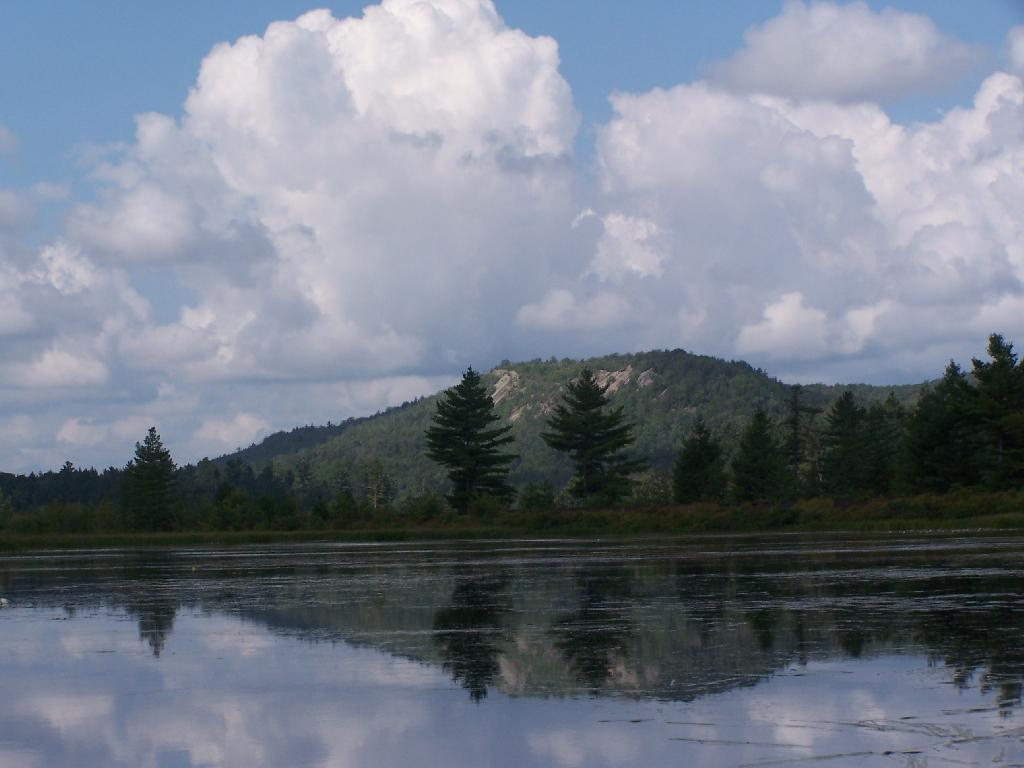What is the primary element visible in the image? There is water in the image. What can be seen in the background of the image? There are trees, plants, a mountain, and clouds in the blue sky in the background of the image. What type of vase can be seen in the image? There is no vase present in the image. What game is being played in the image? There is no game being played in the image. 